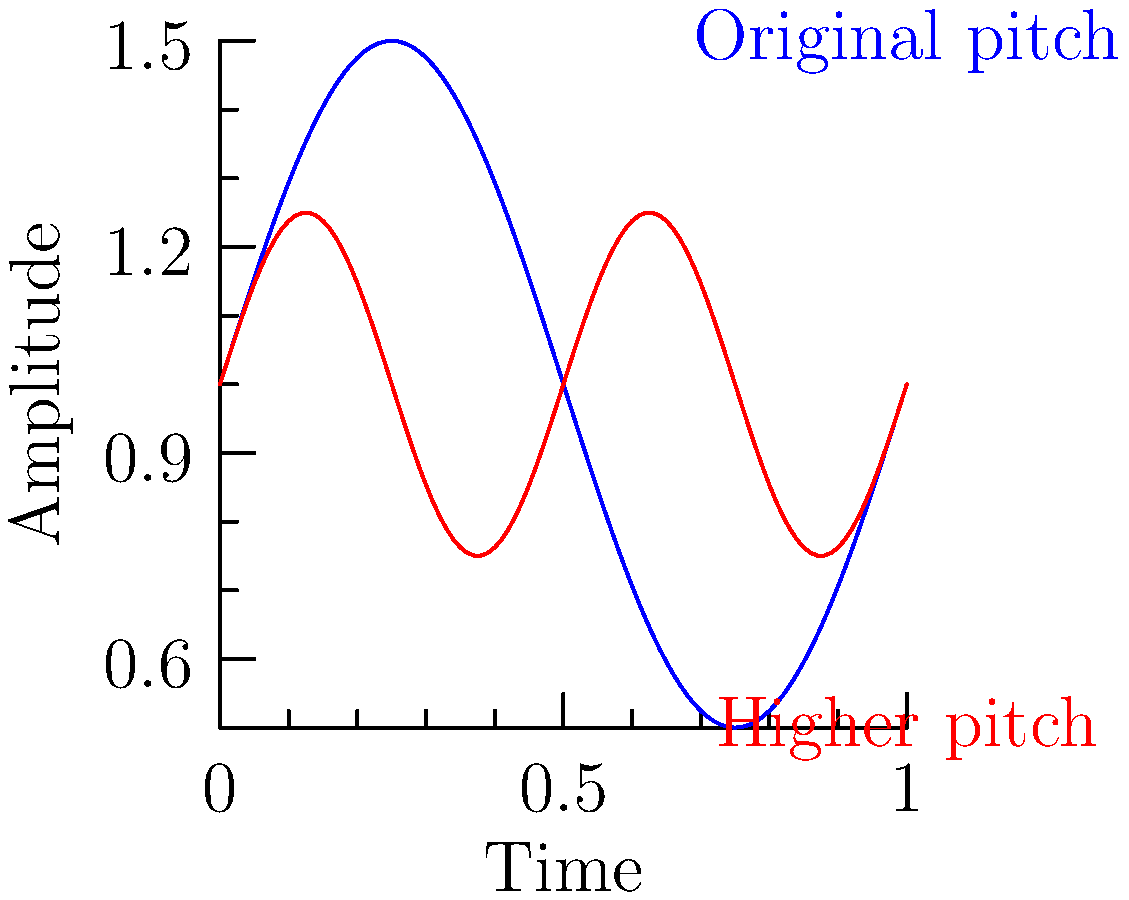Given the audio waveforms shown in the graph, which characteristic of the red waveform indicates a higher pitch compared to the blue waveform? To understand the difference in pitch between the two waveforms, we need to analyze their characteristics:

1. Frequency: The number of cycles per unit time.
2. Wavelength: The distance between two consecutive peaks or troughs.
3. Amplitude: The height of the wave from the centerline.

Step 1: Observe the blue waveform (original pitch).
- It completes one full cycle in the given time frame.

Step 2: Observe the red waveform (higher pitch).
- It completes two full cycles in the same time frame.

Step 3: Compare the frequency.
- The red waveform has a higher frequency (more cycles per unit time).

Step 4: Relate frequency to pitch.
- Higher frequency corresponds to higher pitch in audio.

Step 5: Consider wavelength.
- The red waveform has a shorter wavelength (distance between peaks).

Step 6: Analyze amplitude.
- The amplitude of the red wave is smaller, but this doesn't directly indicate pitch.

Conclusion: The higher frequency (or shorter wavelength) of the red waveform indicates a higher pitch compared to the blue waveform.
Answer: Higher frequency 